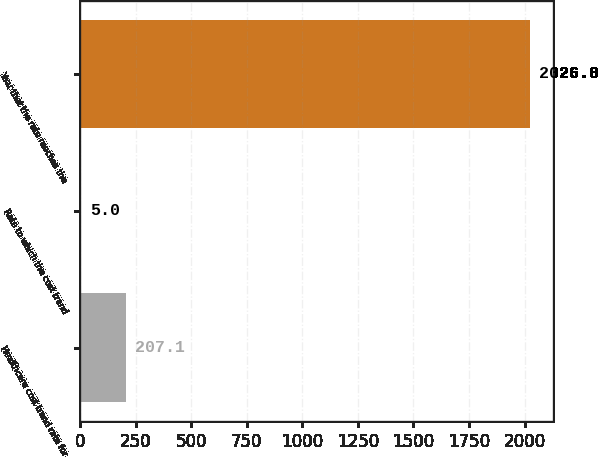<chart> <loc_0><loc_0><loc_500><loc_500><bar_chart><fcel>Healthcare cost trend rate for<fcel>Rate to which the cost trend<fcel>Year that the rate reaches the<nl><fcel>207.1<fcel>5<fcel>2026<nl></chart> 